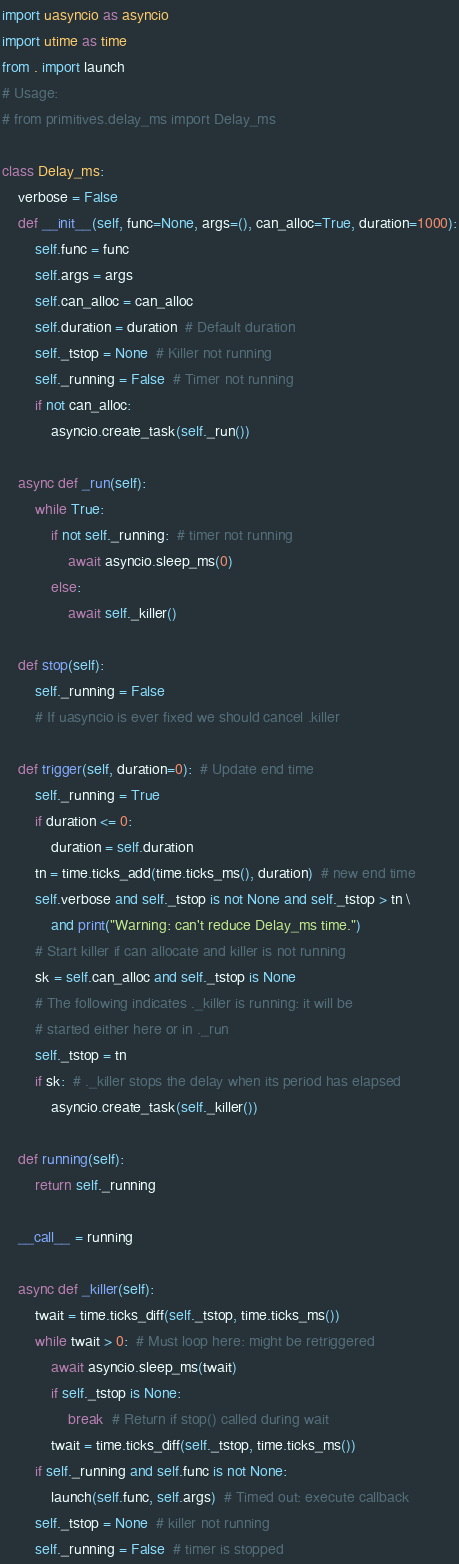<code> <loc_0><loc_0><loc_500><loc_500><_Python_>import uasyncio as asyncio
import utime as time
from . import launch
# Usage:
# from primitives.delay_ms import Delay_ms

class Delay_ms:
    verbose = False
    def __init__(self, func=None, args=(), can_alloc=True, duration=1000):
        self.func = func
        self.args = args
        self.can_alloc = can_alloc
        self.duration = duration  # Default duration
        self._tstop = None  # Killer not running
        self._running = False  # Timer not running
        if not can_alloc:
            asyncio.create_task(self._run())

    async def _run(self):
        while True:
            if not self._running:  # timer not running
                await asyncio.sleep_ms(0)
            else:
                await self._killer()

    def stop(self):
        self._running = False
        # If uasyncio is ever fixed we should cancel .killer

    def trigger(self, duration=0):  # Update end time
        self._running = True
        if duration <= 0:
            duration = self.duration
        tn = time.ticks_add(time.ticks_ms(), duration)  # new end time
        self.verbose and self._tstop is not None and self._tstop > tn \
            and print("Warning: can't reduce Delay_ms time.")
        # Start killer if can allocate and killer is not running
        sk = self.can_alloc and self._tstop is None
        # The following indicates ._killer is running: it will be
        # started either here or in ._run
        self._tstop = tn
        if sk:  # ._killer stops the delay when its period has elapsed
            asyncio.create_task(self._killer())

    def running(self):
        return self._running

    __call__ = running

    async def _killer(self):
        twait = time.ticks_diff(self._tstop, time.ticks_ms())
        while twait > 0:  # Must loop here: might be retriggered
            await asyncio.sleep_ms(twait)
            if self._tstop is None:
                break  # Return if stop() called during wait
            twait = time.ticks_diff(self._tstop, time.ticks_ms())
        if self._running and self.func is not None:
            launch(self.func, self.args)  # Timed out: execute callback
        self._tstop = None  # killer not running
        self._running = False  # timer is stopped
</code> 